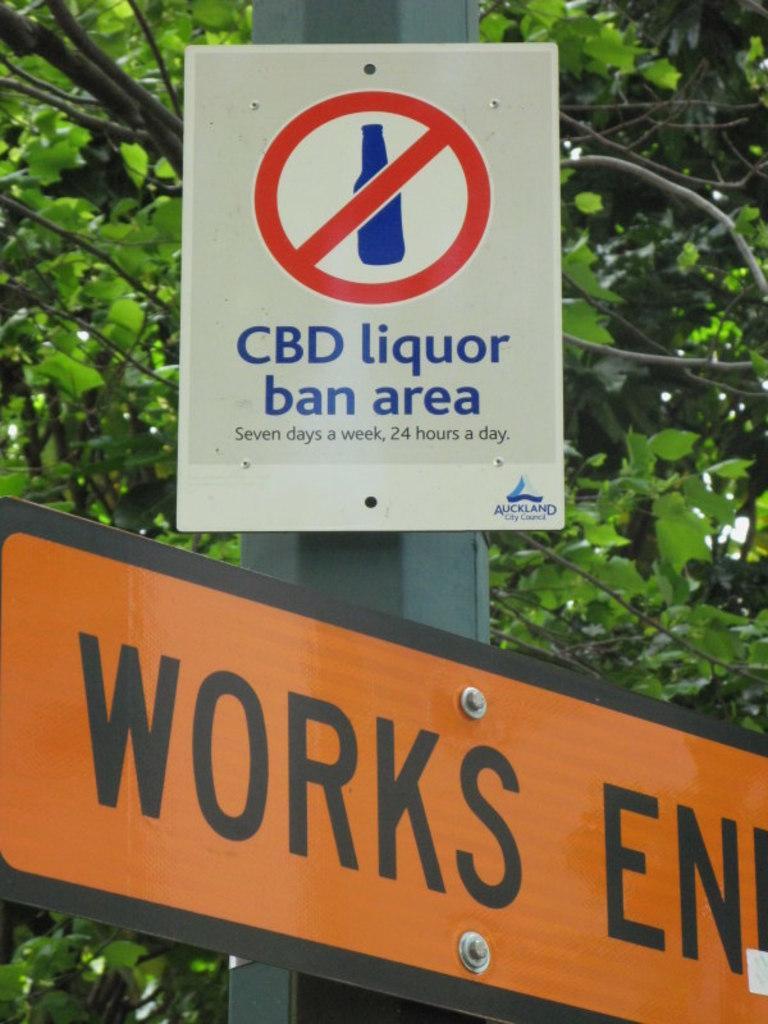Could you give a brief overview of what you see in this image? In this image I can see two boards are attached to a pole. On the boards I can see some text. In the background there is a tree. 